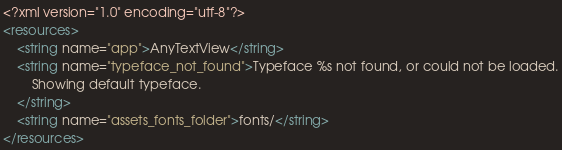<code> <loc_0><loc_0><loc_500><loc_500><_XML_><?xml version="1.0" encoding="utf-8"?>
<resources>
    <string name="app">AnyTextView</string>
    <string name="typeface_not_found">Typeface %s not found, or could not be loaded.
        Showing default typeface.
    </string>
    <string name="assets_fonts_folder">fonts/</string>
</resources></code> 